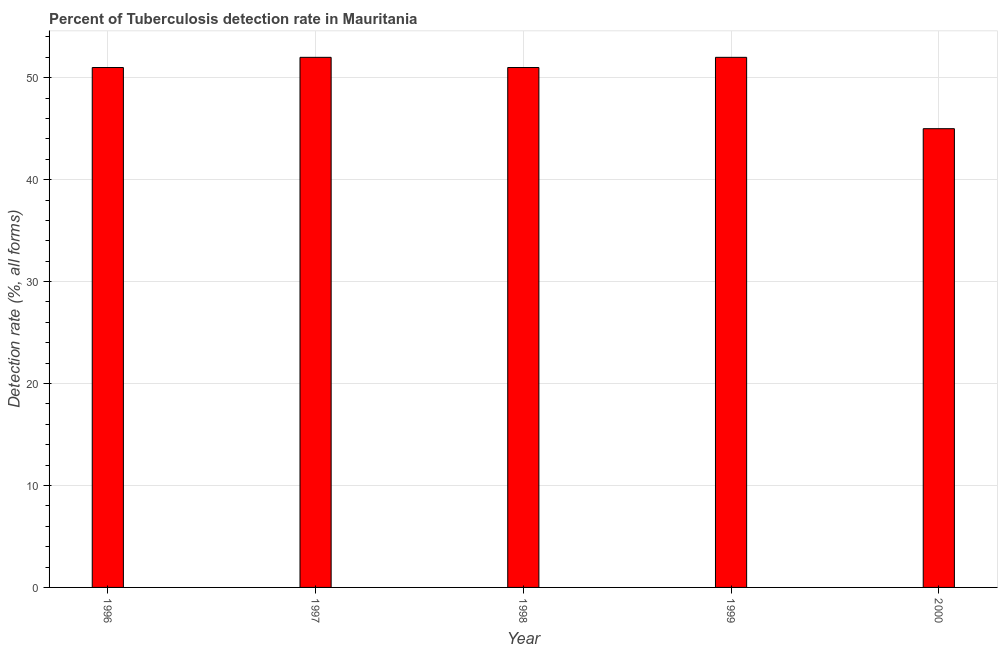What is the title of the graph?
Give a very brief answer. Percent of Tuberculosis detection rate in Mauritania. What is the label or title of the X-axis?
Provide a succinct answer. Year. What is the label or title of the Y-axis?
Your answer should be very brief. Detection rate (%, all forms). What is the detection rate of tuberculosis in 2000?
Make the answer very short. 45. Across all years, what is the minimum detection rate of tuberculosis?
Provide a short and direct response. 45. What is the sum of the detection rate of tuberculosis?
Offer a very short reply. 251. What is the average detection rate of tuberculosis per year?
Your answer should be compact. 50. What is the median detection rate of tuberculosis?
Your answer should be very brief. 51. Do a majority of the years between 1998 and 2000 (inclusive) have detection rate of tuberculosis greater than 42 %?
Ensure brevity in your answer.  Yes. What is the ratio of the detection rate of tuberculosis in 1997 to that in 2000?
Your answer should be compact. 1.16. Is the difference between the detection rate of tuberculosis in 1998 and 1999 greater than the difference between any two years?
Provide a succinct answer. No. What is the difference between the highest and the second highest detection rate of tuberculosis?
Provide a succinct answer. 0. In how many years, is the detection rate of tuberculosis greater than the average detection rate of tuberculosis taken over all years?
Offer a terse response. 4. How many years are there in the graph?
Make the answer very short. 5. Are the values on the major ticks of Y-axis written in scientific E-notation?
Keep it short and to the point. No. What is the Detection rate (%, all forms) of 1996?
Make the answer very short. 51. What is the Detection rate (%, all forms) in 1998?
Provide a short and direct response. 51. What is the Detection rate (%, all forms) in 1999?
Your response must be concise. 52. What is the difference between the Detection rate (%, all forms) in 1996 and 1998?
Your response must be concise. 0. What is the difference between the Detection rate (%, all forms) in 1997 and 2000?
Your response must be concise. 7. What is the difference between the Detection rate (%, all forms) in 1999 and 2000?
Ensure brevity in your answer.  7. What is the ratio of the Detection rate (%, all forms) in 1996 to that in 2000?
Keep it short and to the point. 1.13. What is the ratio of the Detection rate (%, all forms) in 1997 to that in 2000?
Provide a short and direct response. 1.16. What is the ratio of the Detection rate (%, all forms) in 1998 to that in 1999?
Provide a succinct answer. 0.98. What is the ratio of the Detection rate (%, all forms) in 1998 to that in 2000?
Offer a very short reply. 1.13. What is the ratio of the Detection rate (%, all forms) in 1999 to that in 2000?
Your response must be concise. 1.16. 